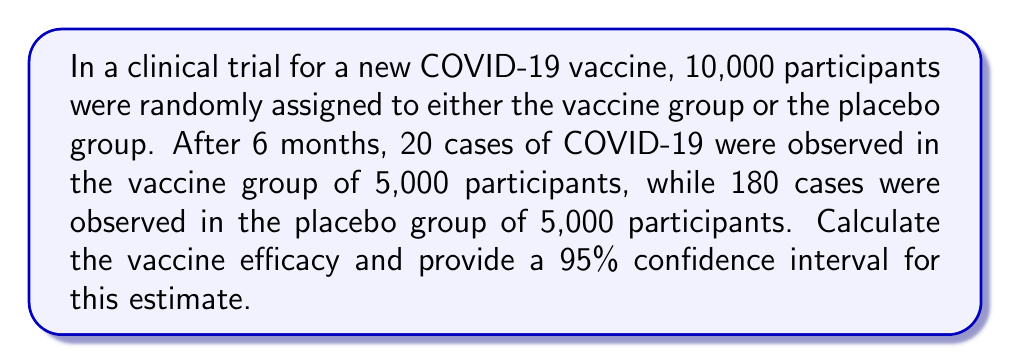Teach me how to tackle this problem. To solve this problem, we'll follow these steps:

1. Calculate the vaccine efficacy (VE)
2. Calculate the standard error of the log risk ratio
3. Compute the 95% confidence interval for the log risk ratio
4. Transform the confidence interval back to the vaccine efficacy scale

Step 1: Calculate vaccine efficacy

Vaccine efficacy is defined as:

$$ VE = 1 - \frac{\text{Risk in vaccinated group}}{\text{Risk in unvaccinated group}} $$

Risk in vaccinated group: $20 / 5000 = 0.004$
Risk in unvaccinated group: $180 / 5000 = 0.036$

$$ VE = 1 - \frac{0.004}{0.036} = 1 - 0.1111 = 0.8889 = 88.89\% $$

Step 2: Calculate the standard error of the log risk ratio

The log risk ratio is:

$$ \ln(RR) = \ln\left(\frac{0.004}{0.036}\right) = -2.197 $$

The standard error of the log risk ratio is:

$$ SE(\ln(RR)) = \sqrt{\frac{1}{20} - \frac{1}{5000} + \frac{1}{180} - \frac{1}{5000}} = 0.2425 $$

Step 3: Compute the 95% confidence interval for the log risk ratio

The 95% CI for the log risk ratio is:

$$ \ln(RR) \pm 1.96 \times SE(\ln(RR)) $$

Lower bound: $-2.197 - (1.96 \times 0.2425) = -2.672$
Upper bound: $-2.197 + (1.96 \times 0.2425) = -1.722$

Step 4: Transform the confidence interval back to the vaccine efficacy scale

Lower bound VE: $1 - e^{-2.672} = 0.9311 = 93.11\%$
Upper bound VE: $1 - e^{-1.722} = 0.8213 = 82.13\%$

Therefore, the 95% confidence interval for the vaccine efficacy is (82.13%, 93.11%).
Answer: Vaccine efficacy: 88.89% (95% CI: 82.13% - 93.11%) 